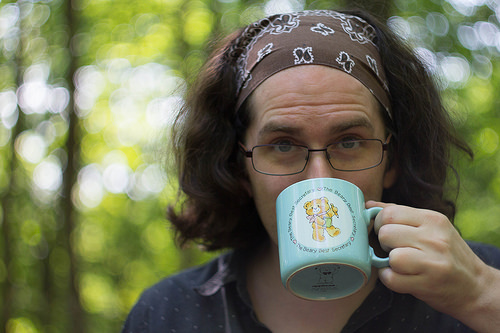<image>
Is the cup under the person? No. The cup is not positioned under the person. The vertical relationship between these objects is different. 